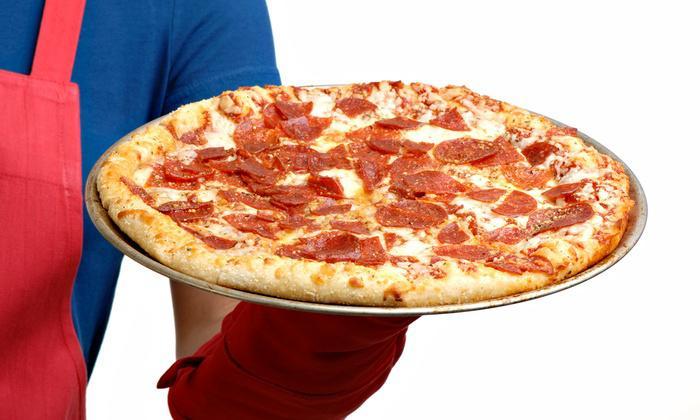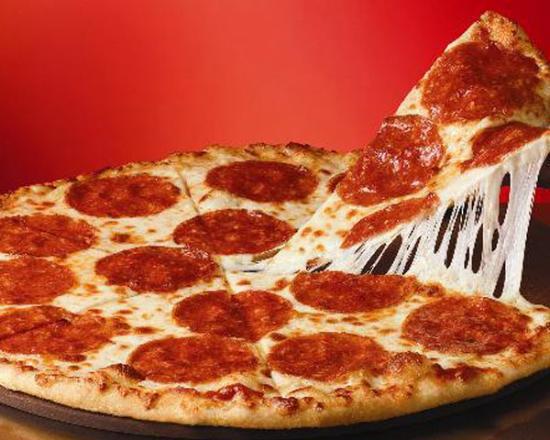The first image is the image on the left, the second image is the image on the right. Evaluate the accuracy of this statement regarding the images: "In one of the images there are tomatoes visible on the table.". Is it true? Answer yes or no. No. The first image is the image on the left, the second image is the image on the right. Given the left and right images, does the statement "One pizza is pepperoni and the other has some green peppers." hold true? Answer yes or no. No. 